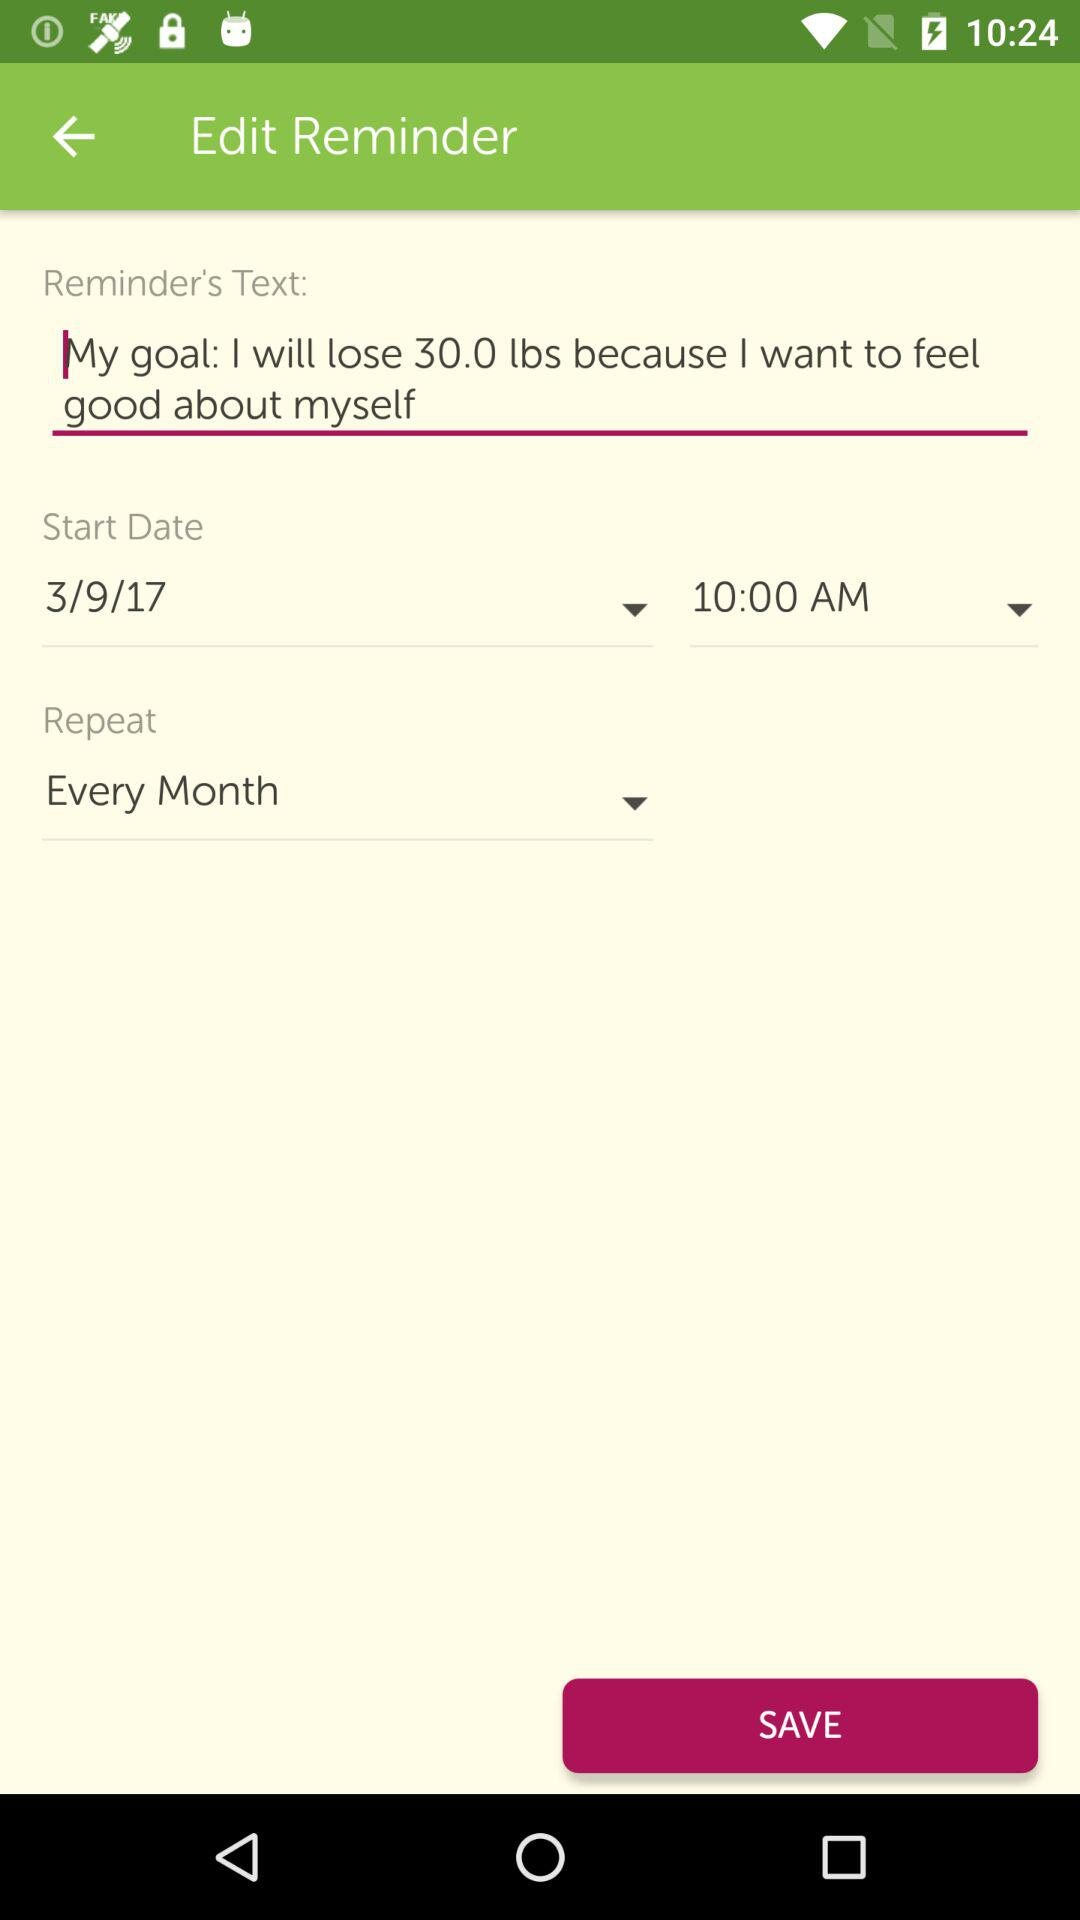What is the reminder's text? The reminder's text is "My goal: I will lose 30.0 lbs because I want to feel good about myself". 